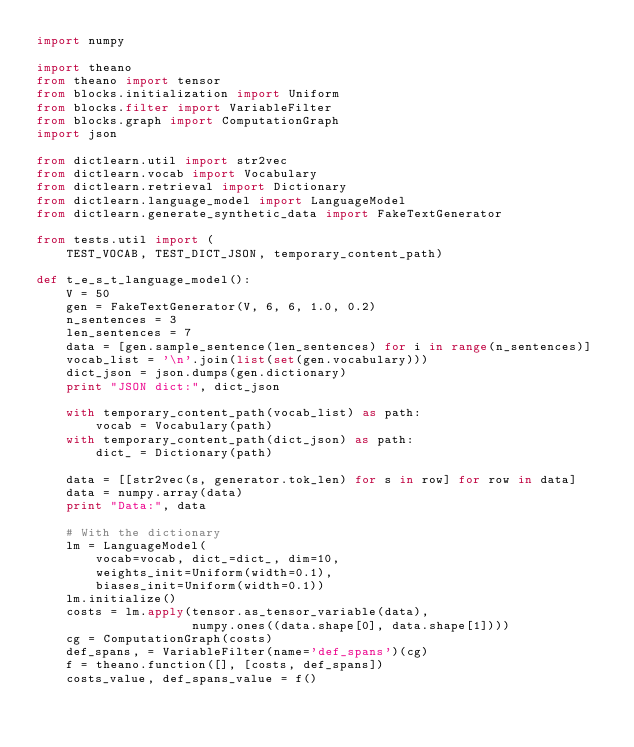Convert code to text. <code><loc_0><loc_0><loc_500><loc_500><_Python_>import numpy

import theano
from theano import tensor
from blocks.initialization import Uniform
from blocks.filter import VariableFilter
from blocks.graph import ComputationGraph
import json

from dictlearn.util import str2vec
from dictlearn.vocab import Vocabulary
from dictlearn.retrieval import Dictionary
from dictlearn.language_model import LanguageModel
from dictlearn.generate_synthetic_data import FakeTextGenerator

from tests.util import (
    TEST_VOCAB, TEST_DICT_JSON, temporary_content_path)

def t_e_s_t_language_model():
    V = 50
    gen = FakeTextGenerator(V, 6, 6, 1.0, 0.2)
    n_sentences = 3
    len_sentences = 7
    data = [gen.sample_sentence(len_sentences) for i in range(n_sentences)]
    vocab_list = '\n'.join(list(set(gen.vocabulary)))
    dict_json = json.dumps(gen.dictionary)
    print "JSON dict:", dict_json

    with temporary_content_path(vocab_list) as path:
        vocab = Vocabulary(path)
    with temporary_content_path(dict_json) as path:
        dict_ = Dictionary(path)

    data = [[str2vec(s, generator.tok_len) for s in row] for row in data]
    data = numpy.array(data)
    print "Data:", data

    # With the dictionary
    lm = LanguageModel(
        vocab=vocab, dict_=dict_, dim=10,
        weights_init=Uniform(width=0.1),
        biases_init=Uniform(width=0.1))
    lm.initialize()
    costs = lm.apply(tensor.as_tensor_variable(data),
                     numpy.ones((data.shape[0], data.shape[1])))
    cg = ComputationGraph(costs)
    def_spans, = VariableFilter(name='def_spans')(cg)
    f = theano.function([], [costs, def_spans])
    costs_value, def_spans_value = f()</code> 